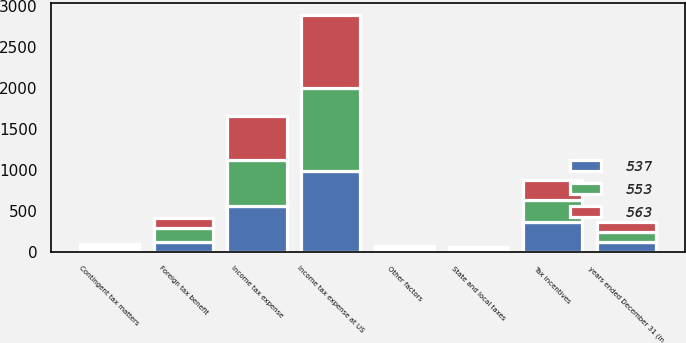Convert chart to OTSL. <chart><loc_0><loc_0><loc_500><loc_500><stacked_bar_chart><ecel><fcel>years ended December 31 (in<fcel>Income tax expense at US<fcel>Tax incentives<fcel>State and local taxes<fcel>Foreign tax benefit<fcel>Contingent tax matters<fcel>Other factors<fcel>Income tax expense<nl><fcel>563<fcel>122<fcel>892<fcel>240<fcel>22<fcel>122<fcel>26<fcel>41<fcel>537<nl><fcel>553<fcel>122<fcel>1011<fcel>277<fcel>11<fcel>177<fcel>30<fcel>13<fcel>563<nl><fcel>537<fcel>122<fcel>983<fcel>360<fcel>25<fcel>118<fcel>39<fcel>16<fcel>553<nl></chart> 